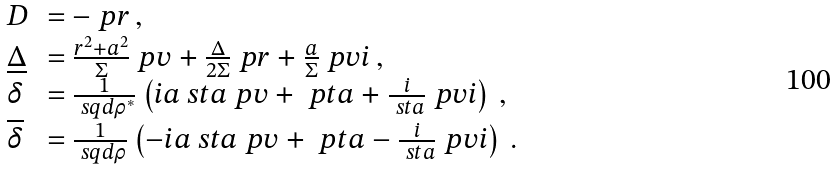Convert formula to latex. <formula><loc_0><loc_0><loc_500><loc_500>\begin{array} { l l } D & = - \ p r \, , \\ \underline { \Delta } & = \frac { r ^ { 2 } + a ^ { 2 } } { \Sigma } \ p v + \frac { \Delta } { 2 \Sigma } \ p r + \frac { a } { \Sigma } \ p v i \, , \\ \delta & = \frac { 1 } { \ s q d \rho ^ { * } } \left ( i a \ s t a \ p v + \ p t a + \frac { i } { \ s t a } \ p v i \right ) \, , \\ \overline { \delta } & = \frac { 1 } { \ s q d \rho } \left ( - i a \ s t a \ p v + \ p t a - \frac { i } { \ s t a } \ p v i \right ) \, . \end{array}</formula> 